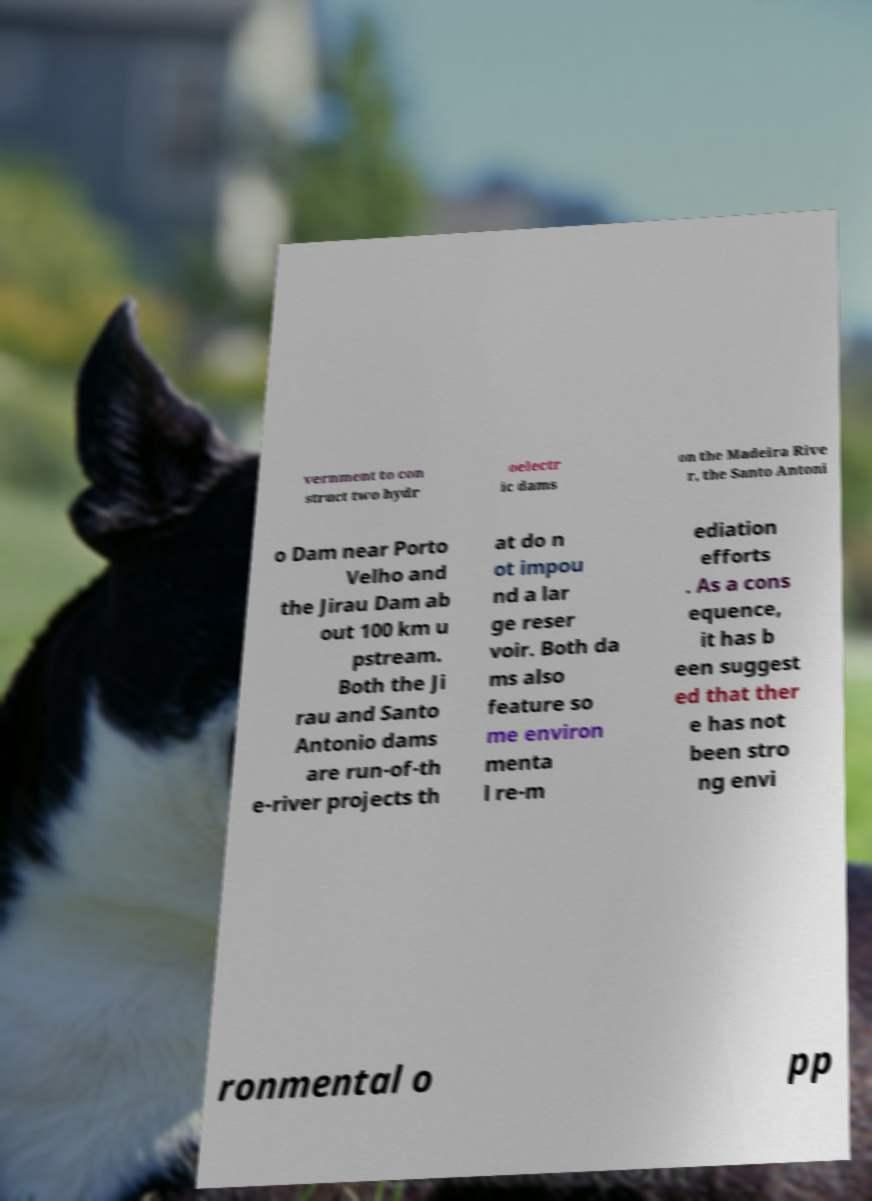Please identify and transcribe the text found in this image. vernment to con struct two hydr oelectr ic dams on the Madeira Rive r, the Santo Antoni o Dam near Porto Velho and the Jirau Dam ab out 100 km u pstream. Both the Ji rau and Santo Antonio dams are run-of-th e-river projects th at do n ot impou nd a lar ge reser voir. Both da ms also feature so me environ menta l re-m ediation efforts . As a cons equence, it has b een suggest ed that ther e has not been stro ng envi ronmental o pp 